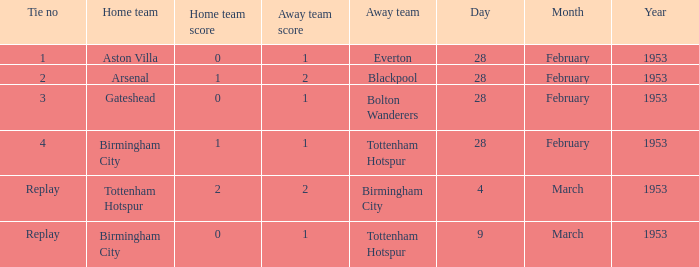What score has aston villa's home team achieved? 0–1. 